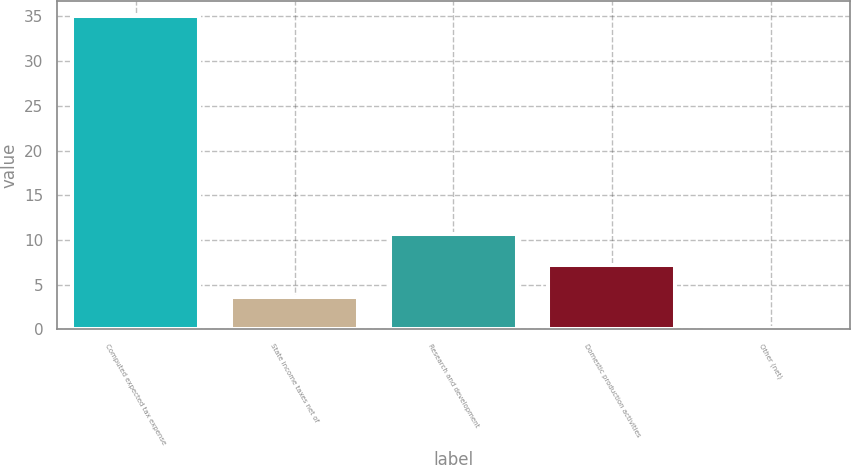Convert chart to OTSL. <chart><loc_0><loc_0><loc_500><loc_500><bar_chart><fcel>Computed expected tax expense<fcel>State income taxes net of<fcel>Research and development<fcel>Domestic production activities<fcel>Other (net)<nl><fcel>35<fcel>3.68<fcel>10.64<fcel>7.16<fcel>0.2<nl></chart> 